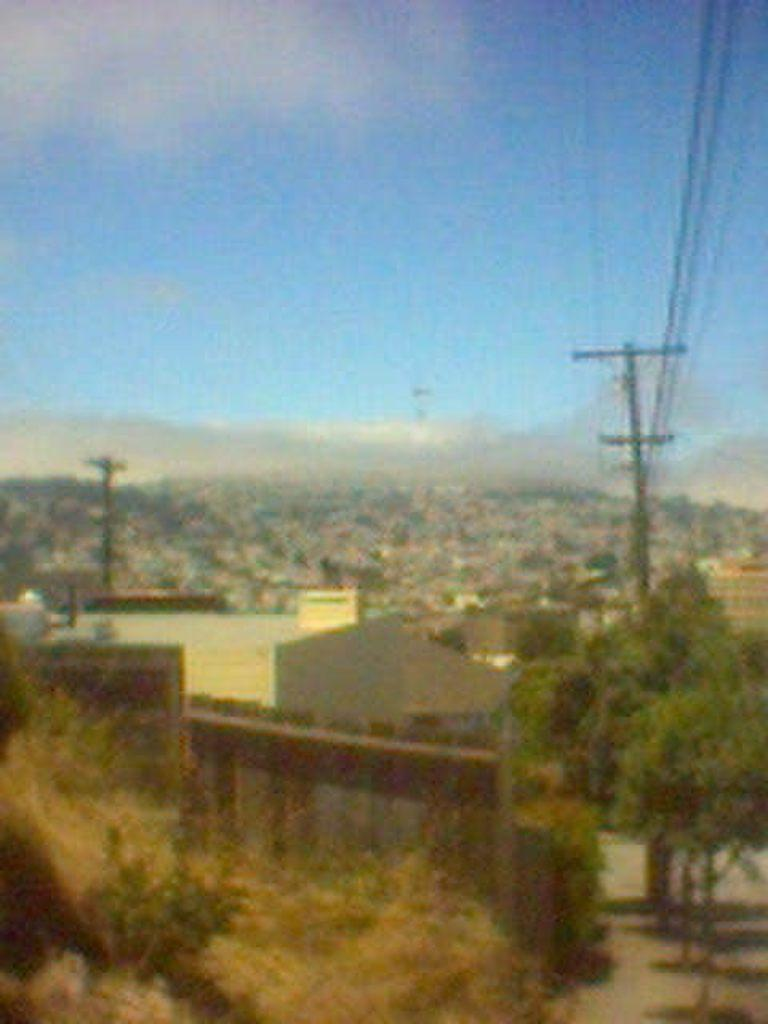What type of structures can be seen in the image? There are houses in the image. What type of vegetation is present in the image? There are trees in the image. What other objects can be seen in the image? There are poles and wires in the image. What is visible in the background of the image? There are mountains and the sky in the background of the image. How would you describe the overall appearance of the image? The image is blurred. Can you see any dinosaurs roaming around in the image? No, there are no dinosaurs present in the image. What type of force is being exerted on the mountains in the image? There is no force being exerted on the mountains in the image; they are simply part of the background. 